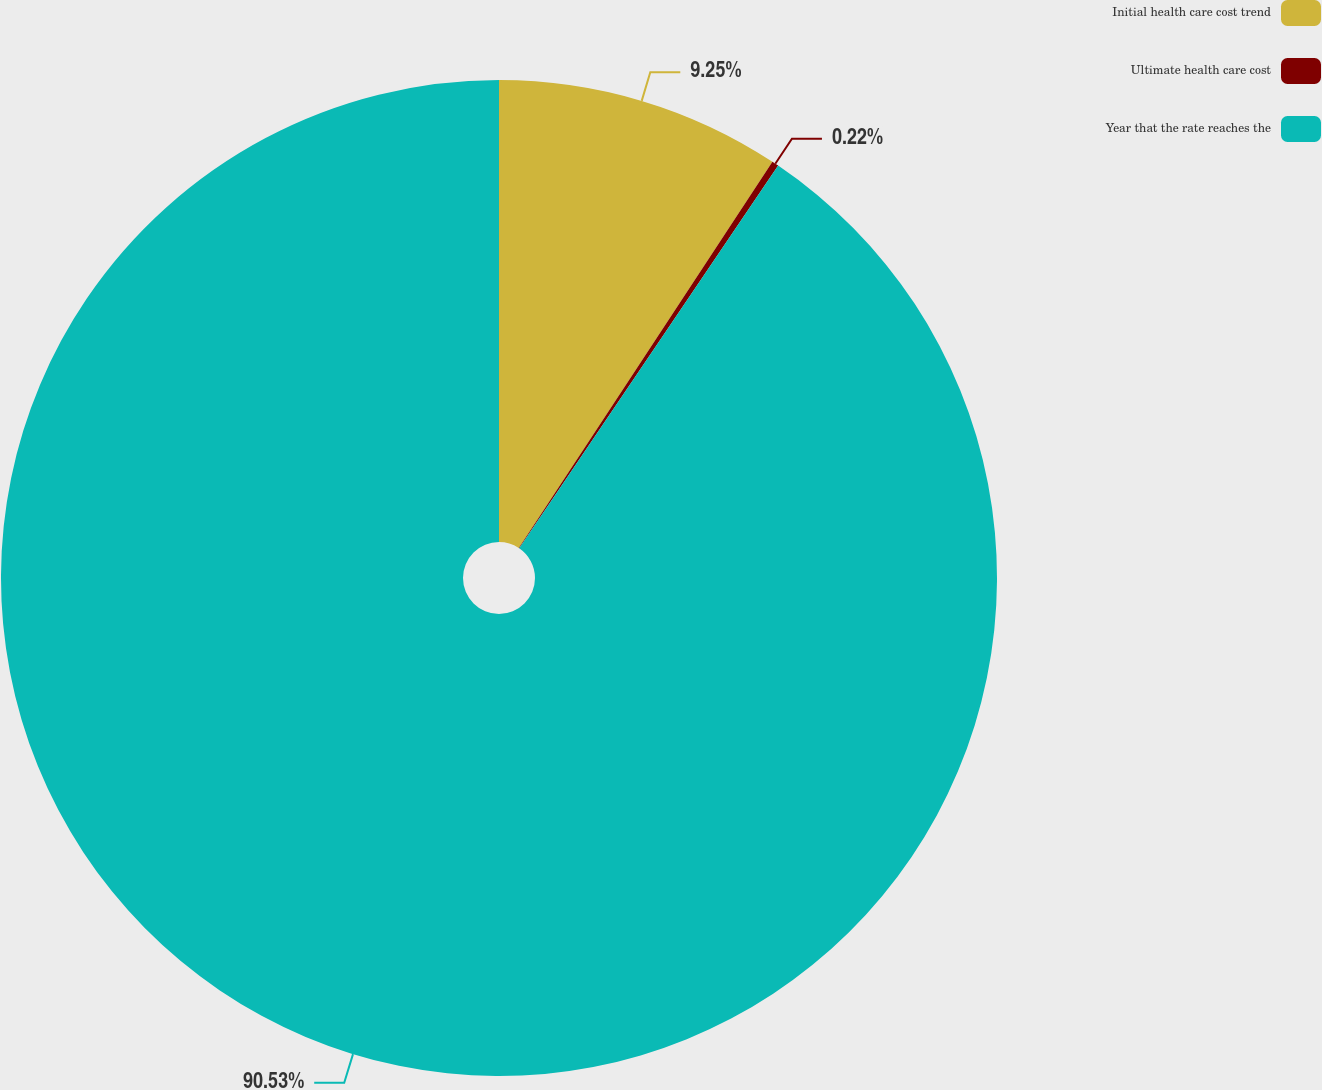Convert chart to OTSL. <chart><loc_0><loc_0><loc_500><loc_500><pie_chart><fcel>Initial health care cost trend<fcel>Ultimate health care cost<fcel>Year that the rate reaches the<nl><fcel>9.25%<fcel>0.22%<fcel>90.52%<nl></chart> 